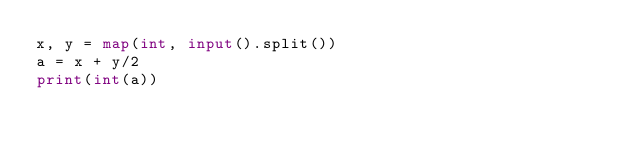<code> <loc_0><loc_0><loc_500><loc_500><_Python_>x, y = map(int, input().split())
a = x + y/2
print(int(a))</code> 